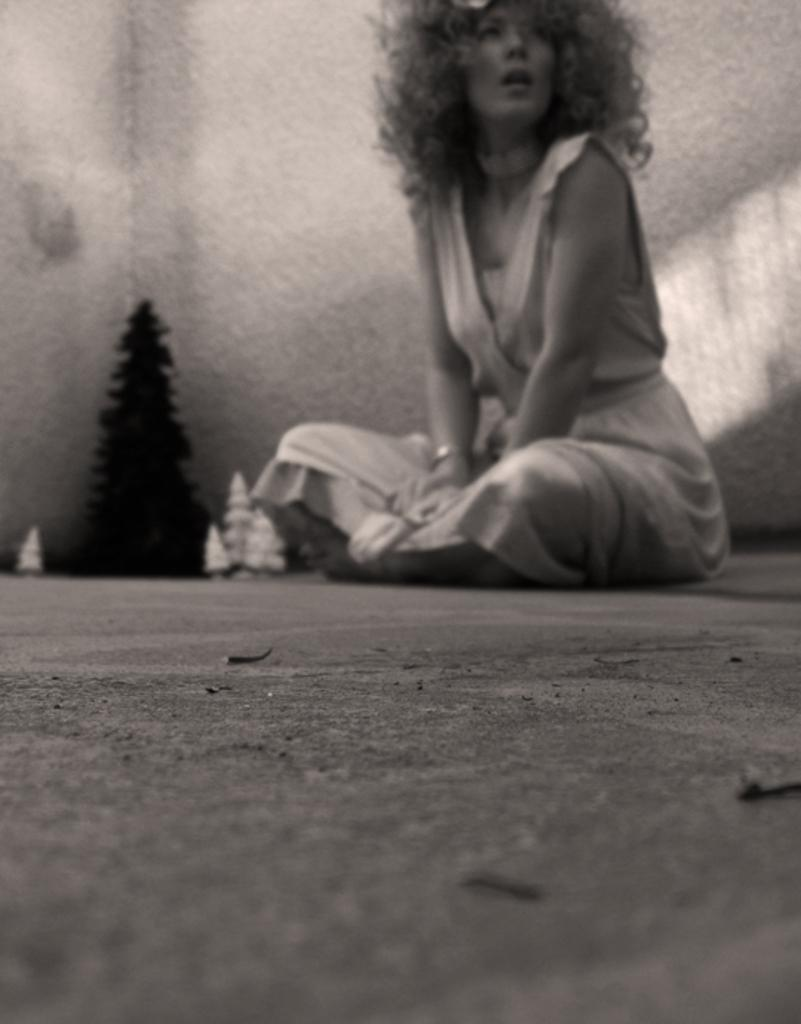What is the woman in the image doing? The woman is sitting on the floor in the image. What can be seen behind the woman? There is a wall visible behind the woman. Are there any objects or features in front of the wall? There might be toy trees in front of the wall. Can you tell me how deep the lake is in the image? There is no lake present in the image. 